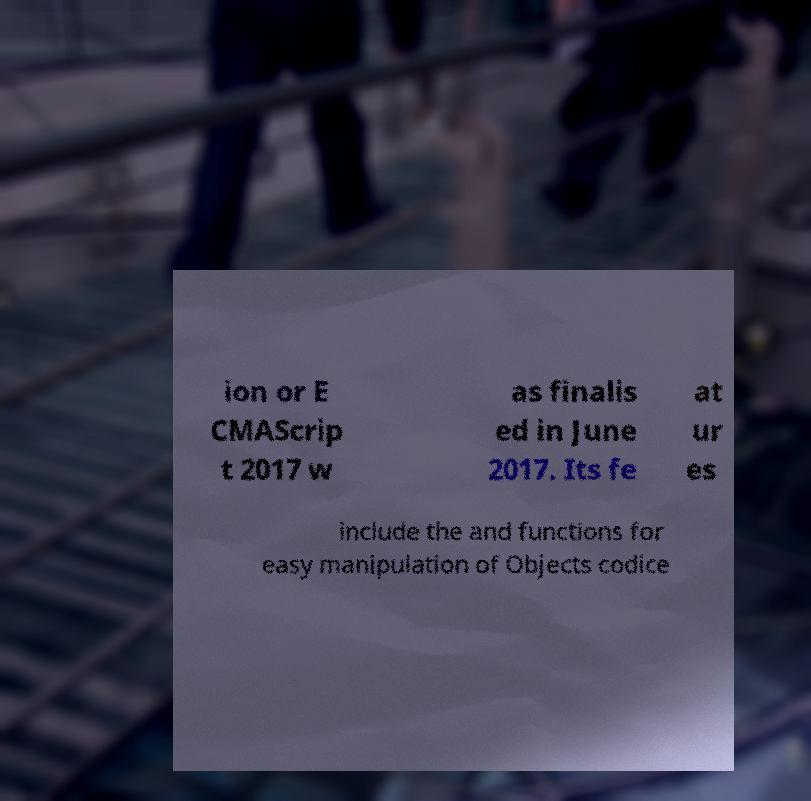Can you read and provide the text displayed in the image?This photo seems to have some interesting text. Can you extract and type it out for me? ion or E CMAScrip t 2017 w as finalis ed in June 2017. Its fe at ur es include the and functions for easy manipulation of Objects codice 